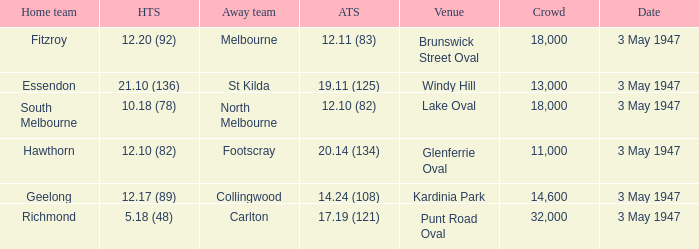Which venue did the away team score 12.10 (82)? Lake Oval. 